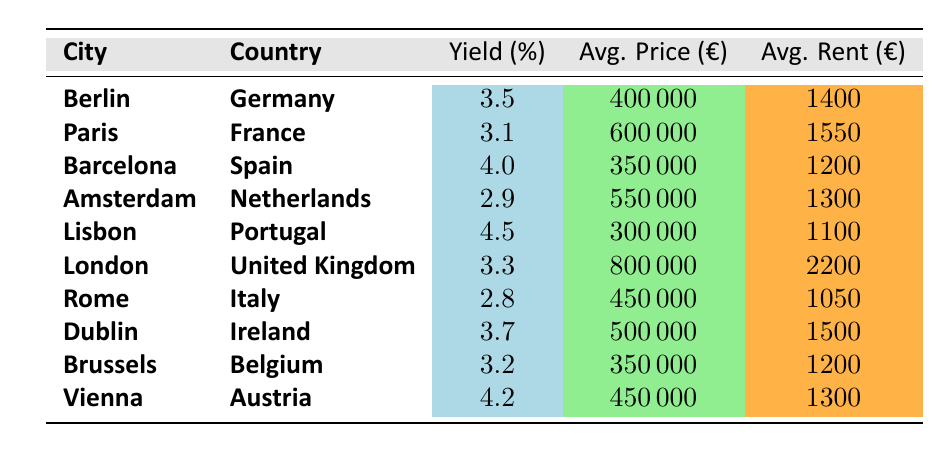What is the highest rental yield percentage among the listed cities? The table shows the rental yield percentages for different cities. The highest value is 4.5%, which is associated with Lisbon.
Answer: 4.5% What is the average property price in Amsterdam? The table indicates that the average property price in Amsterdam is listed as €550,000.
Answer: €550,000 Is the rental yield in Berlin higher than that in Paris? Berlin has a rental yield of 3.5% while Paris has a lower yield of 3.1%. Thus, Berlin's yield is higher.
Answer: Yes Which city has the lowest rental yield? By inspecting the rental yield percentages, Rome has the lowest yield at 2.8%.
Answer: Rome What are the average rent values for cities with rental yields over 4%? The cities with rental yields over 4% are Barcelona (average rent €1200), Lisbon (€1100), and Vienna (€1300). The average rent is thus calculated as (1200 + 1100 + 1300) / 3 = 1200.
Answer: €1200 What is the difference in rental yield between Berlin and Dublin? The rental yield for Berlin is 3.5% and for Dublin is 3.7%. To find the difference, we calculate 3.7% - 3.5% = 0.2%.
Answer: 0.2% What is the total average rent for all cities listed? To find the total average rent, we sum up all average rents represented in the table (1400 + 1550 + 1200 + 1300 + 1100 + 2200 + 1050 + 1500 + 1200 + 1300 =  13500) and divide by the number of cities (10): 13500 / 10 = 1350.
Answer: €1350 Which city has the highest average property price? The average property price in London is €800,000, which is higher than the other cities listed.
Answer: London Is the average rent in Vienna higher than that in Lisbon? Vienna has an average rent of €1300 while Lisbon's average rent is €1100. Since €1300 is greater than €1100, Vienna's average rent is higher.
Answer: Yes What is the average rental yield for the cities listed in Spain? The only city listed in Spain is Barcelona which has a rental yield of 4.0%. Thus, the average yield for Spain is 4.0%.
Answer: 4.0% 